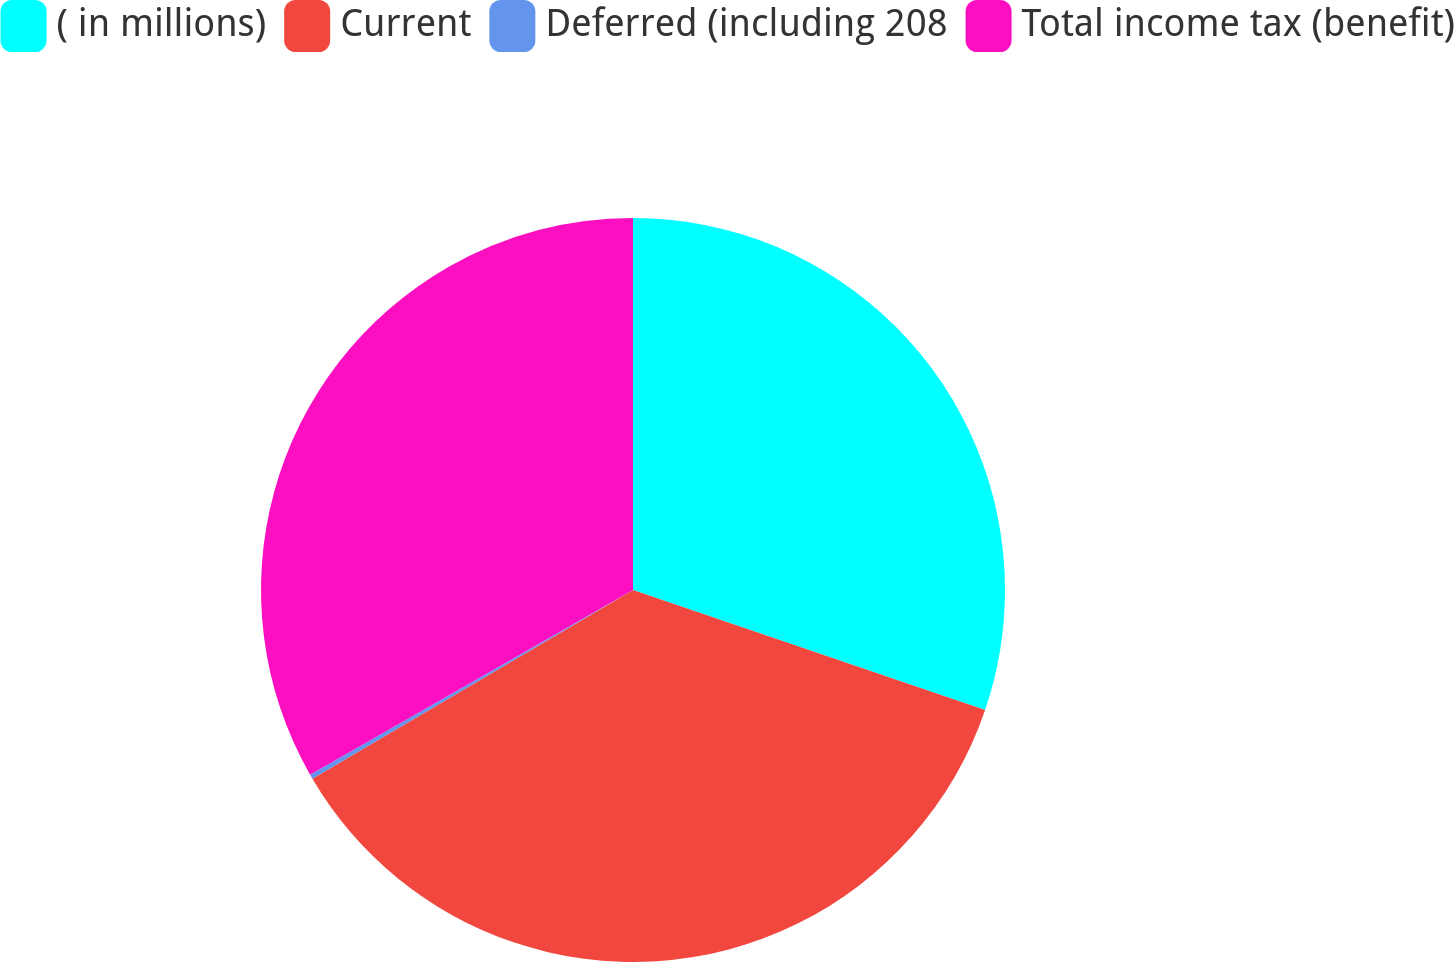<chart> <loc_0><loc_0><loc_500><loc_500><pie_chart><fcel>( in millions)<fcel>Current<fcel>Deferred (including 208<fcel>Total income tax (benefit)<nl><fcel>30.23%<fcel>36.31%<fcel>0.2%<fcel>33.27%<nl></chart> 